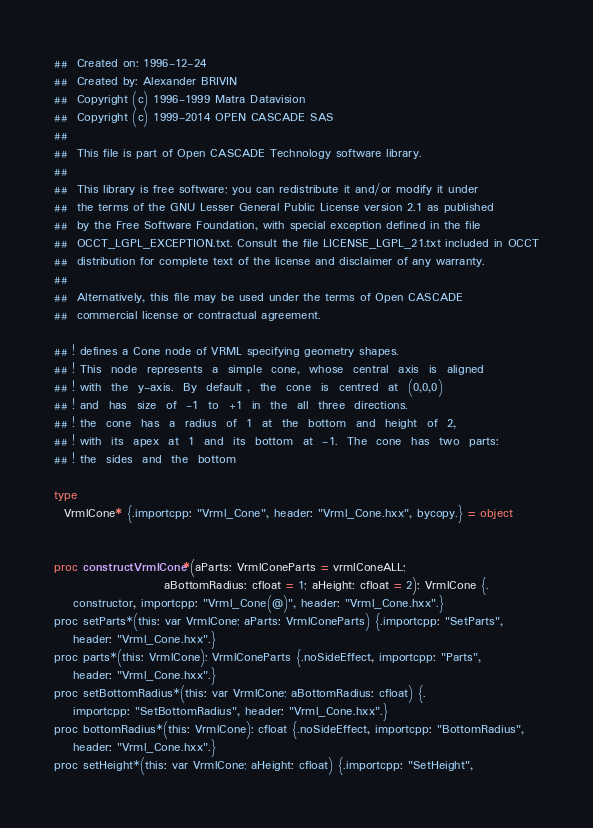Convert code to text. <code><loc_0><loc_0><loc_500><loc_500><_Nim_>##  Created on: 1996-12-24
##  Created by: Alexander BRIVIN
##  Copyright (c) 1996-1999 Matra Datavision
##  Copyright (c) 1999-2014 OPEN CASCADE SAS
##
##  This file is part of Open CASCADE Technology software library.
##
##  This library is free software; you can redistribute it and/or modify it under
##  the terms of the GNU Lesser General Public License version 2.1 as published
##  by the Free Software Foundation, with special exception defined in the file
##  OCCT_LGPL_EXCEPTION.txt. Consult the file LICENSE_LGPL_21.txt included in OCCT
##  distribution for complete text of the license and disclaimer of any warranty.
##
##  Alternatively, this file may be used under the terms of Open CASCADE
##  commercial license or contractual agreement.

## ! defines a Cone node of VRML specifying geometry shapes.
## ! This  node  represents  a  simple  cone,  whose  central  axis  is  aligned
## ! with  the  y-axis.  By  default ,  the  cone  is  centred  at  (0,0,0)
## ! and  has  size  of  -1  to  +1  in  the  all  three  directions.
## ! the  cone  has  a  radius  of  1  at  the  bottom  and  height  of  2,
## ! with  its  apex  at  1  and  its  bottom  at  -1.  The  cone  has  two  parts:
## ! the  sides  and  the  bottom

type
  VrmlCone* {.importcpp: "Vrml_Cone", header: "Vrml_Cone.hxx", bycopy.} = object


proc constructVrmlCone*(aParts: VrmlConeParts = vrmlConeALL;
                       aBottomRadius: cfloat = 1; aHeight: cfloat = 2): VrmlCone {.
    constructor, importcpp: "Vrml_Cone(@)", header: "Vrml_Cone.hxx".}
proc setParts*(this: var VrmlCone; aParts: VrmlConeParts) {.importcpp: "SetParts",
    header: "Vrml_Cone.hxx".}
proc parts*(this: VrmlCone): VrmlConeParts {.noSideEffect, importcpp: "Parts",
    header: "Vrml_Cone.hxx".}
proc setBottomRadius*(this: var VrmlCone; aBottomRadius: cfloat) {.
    importcpp: "SetBottomRadius", header: "Vrml_Cone.hxx".}
proc bottomRadius*(this: VrmlCone): cfloat {.noSideEffect, importcpp: "BottomRadius",
    header: "Vrml_Cone.hxx".}
proc setHeight*(this: var VrmlCone; aHeight: cfloat) {.importcpp: "SetHeight",</code> 